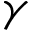Convert formula to latex. <formula><loc_0><loc_0><loc_500><loc_500>\gamma</formula> 